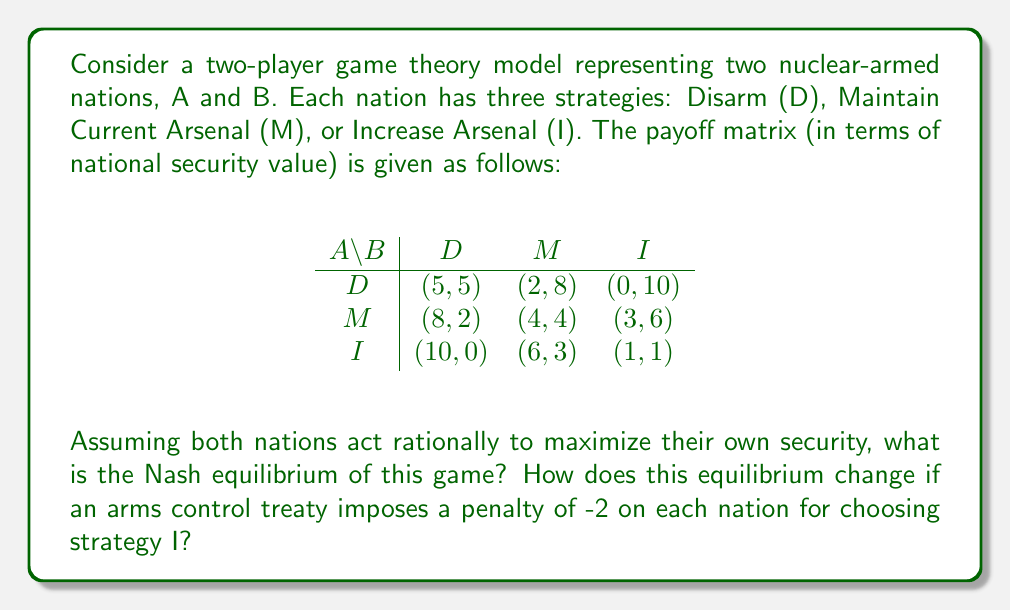Could you help me with this problem? To solve this problem, we'll follow these steps:

1) First, let's identify the Nash equilibrium without the treaty:
   - For each strategy of nation B, we find the best response of nation A (underlined):
     D: (5,5), (\underline{8},2), (\underline{10},0)
     M: (2,8), (\underline{4},4), (\underline{6},3)
     I: (0,10), (\underline{3},6), (\underline{1},1)
   - For each strategy of nation A, we find the best response of nation B (in bold):
     D: (5,5), (2,8), (0,**10**)
     M: (8,2), (4,4), (3,**6**)
     I: (**10**,0), (6,3), (1,1)

   The Nash equilibrium is where both are underlined and bold: (M,M) with payoff (4,4).

2) Now, let's apply the treaty penalty and recalculate:
   The new payoff matrix becomes:
   $$
   \begin{array}{c|ccc}
   A \backslash B & D & M & I \\
   \hline
   D & (5,5) & (2,8) & (0,8) \\
   M & (8,2) & (4,4) & (3,4) \\
   I & (8,0) & (4,3) & (-1,-1)
   \end{array}
   $$

3) We repeat the process to find the new Nash equilibrium:
   - Best responses for A:
     D: (5,5), (\underline{8},2), (\underline{8},0)
     M: (2,8), (\underline{4},4), (\underline{3},4)
     I: (0,8), (3,4), (-1,-1)
   - Best responses for B:
     D: (5,5), (2,**8**), (0,**8**)
     M: (**8**,2), (4,4), (3,4)
     I: (**8**,0), (4,3), (-1,-1)

   The new Nash equilibrium is (M,M) with payoff (4,4).

4) Comparing the results:
   - Without the treaty, the Nash equilibrium was (M,M) with payoff (4,4).
   - With the treaty, the Nash equilibrium remains (M,M) with payoff (4,4).

The equilibrium strategy doesn't change, but the treaty removes the incentive to increase arsenals, potentially leading to more stable international relations.
Answer: Nash equilibrium remains (M,M) with payoff (4,4); treaty stabilizes by disincentivizing arsenal increase. 